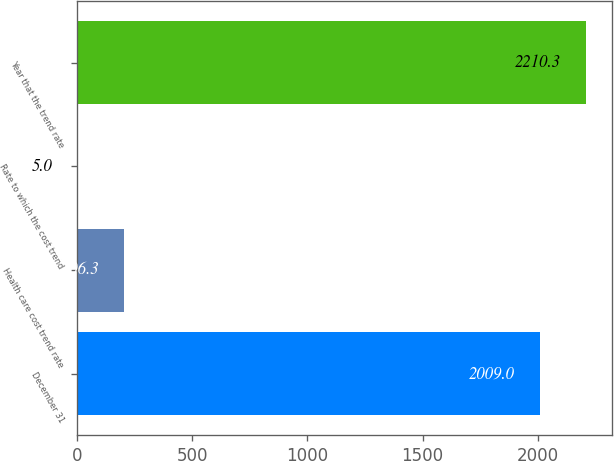<chart> <loc_0><loc_0><loc_500><loc_500><bar_chart><fcel>December 31<fcel>Health care cost trend rate<fcel>Rate to which the cost trend<fcel>Year that the trend rate<nl><fcel>2009<fcel>206.3<fcel>5<fcel>2210.3<nl></chart> 